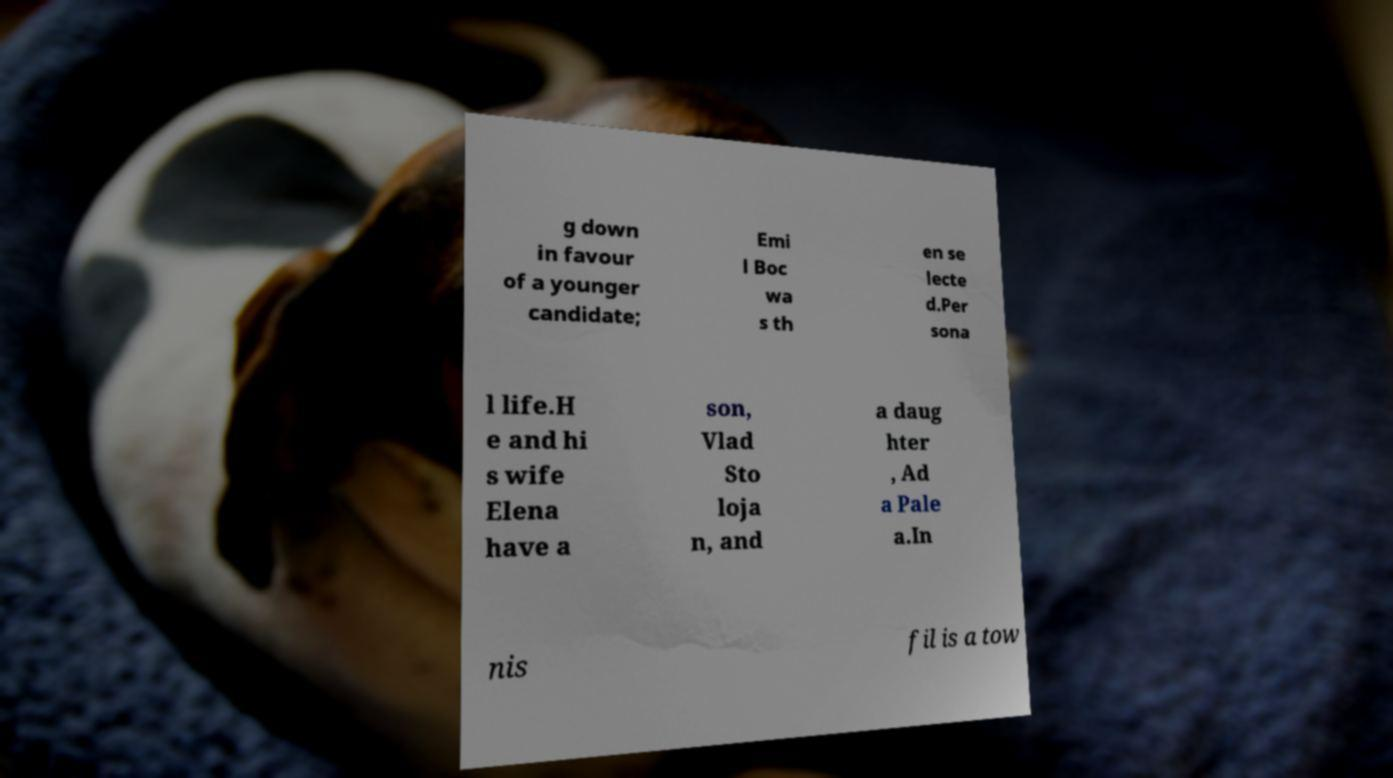Can you accurately transcribe the text from the provided image for me? g down in favour of a younger candidate; Emi l Boc wa s th en se lecte d.Per sona l life.H e and hi s wife Elena have a son, Vlad Sto loja n, and a daug hter , Ad a Pale a.In nis fil is a tow 